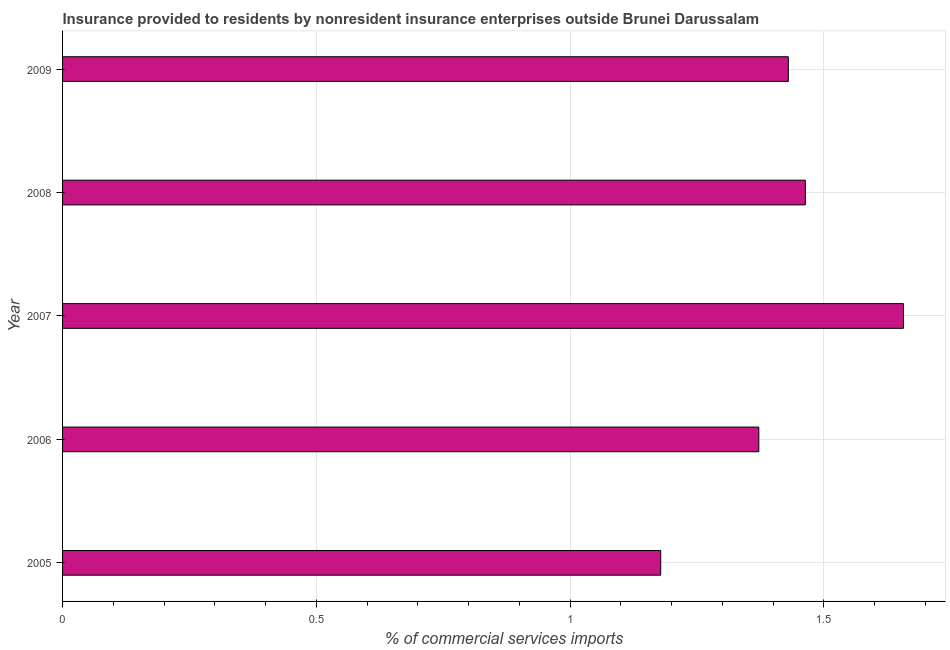Does the graph contain any zero values?
Keep it short and to the point. No. Does the graph contain grids?
Your response must be concise. Yes. What is the title of the graph?
Make the answer very short. Insurance provided to residents by nonresident insurance enterprises outside Brunei Darussalam. What is the label or title of the X-axis?
Give a very brief answer. % of commercial services imports. What is the insurance provided by non-residents in 2009?
Your answer should be compact. 1.43. Across all years, what is the maximum insurance provided by non-residents?
Ensure brevity in your answer.  1.66. Across all years, what is the minimum insurance provided by non-residents?
Offer a very short reply. 1.18. In which year was the insurance provided by non-residents maximum?
Offer a very short reply. 2007. What is the sum of the insurance provided by non-residents?
Your answer should be compact. 7.1. What is the difference between the insurance provided by non-residents in 2006 and 2007?
Provide a short and direct response. -0.28. What is the average insurance provided by non-residents per year?
Give a very brief answer. 1.42. What is the median insurance provided by non-residents?
Give a very brief answer. 1.43. What is the ratio of the insurance provided by non-residents in 2005 to that in 2009?
Provide a short and direct response. 0.82. Is the insurance provided by non-residents in 2005 less than that in 2008?
Make the answer very short. Yes. What is the difference between the highest and the second highest insurance provided by non-residents?
Keep it short and to the point. 0.19. What is the difference between the highest and the lowest insurance provided by non-residents?
Offer a very short reply. 0.48. Are the values on the major ticks of X-axis written in scientific E-notation?
Make the answer very short. No. What is the % of commercial services imports in 2005?
Your response must be concise. 1.18. What is the % of commercial services imports of 2006?
Ensure brevity in your answer.  1.37. What is the % of commercial services imports of 2007?
Offer a terse response. 1.66. What is the % of commercial services imports of 2008?
Offer a very short reply. 1.46. What is the % of commercial services imports of 2009?
Your answer should be very brief. 1.43. What is the difference between the % of commercial services imports in 2005 and 2006?
Ensure brevity in your answer.  -0.19. What is the difference between the % of commercial services imports in 2005 and 2007?
Give a very brief answer. -0.48. What is the difference between the % of commercial services imports in 2005 and 2008?
Provide a succinct answer. -0.29. What is the difference between the % of commercial services imports in 2005 and 2009?
Offer a terse response. -0.25. What is the difference between the % of commercial services imports in 2006 and 2007?
Make the answer very short. -0.28. What is the difference between the % of commercial services imports in 2006 and 2008?
Offer a terse response. -0.09. What is the difference between the % of commercial services imports in 2006 and 2009?
Keep it short and to the point. -0.06. What is the difference between the % of commercial services imports in 2007 and 2008?
Offer a very short reply. 0.19. What is the difference between the % of commercial services imports in 2007 and 2009?
Offer a terse response. 0.23. What is the difference between the % of commercial services imports in 2008 and 2009?
Your answer should be very brief. 0.03. What is the ratio of the % of commercial services imports in 2005 to that in 2006?
Offer a very short reply. 0.86. What is the ratio of the % of commercial services imports in 2005 to that in 2007?
Provide a succinct answer. 0.71. What is the ratio of the % of commercial services imports in 2005 to that in 2008?
Ensure brevity in your answer.  0.81. What is the ratio of the % of commercial services imports in 2005 to that in 2009?
Offer a terse response. 0.82. What is the ratio of the % of commercial services imports in 2006 to that in 2007?
Provide a succinct answer. 0.83. What is the ratio of the % of commercial services imports in 2006 to that in 2008?
Provide a succinct answer. 0.94. What is the ratio of the % of commercial services imports in 2007 to that in 2008?
Make the answer very short. 1.13. What is the ratio of the % of commercial services imports in 2007 to that in 2009?
Make the answer very short. 1.16. What is the ratio of the % of commercial services imports in 2008 to that in 2009?
Keep it short and to the point. 1.02. 